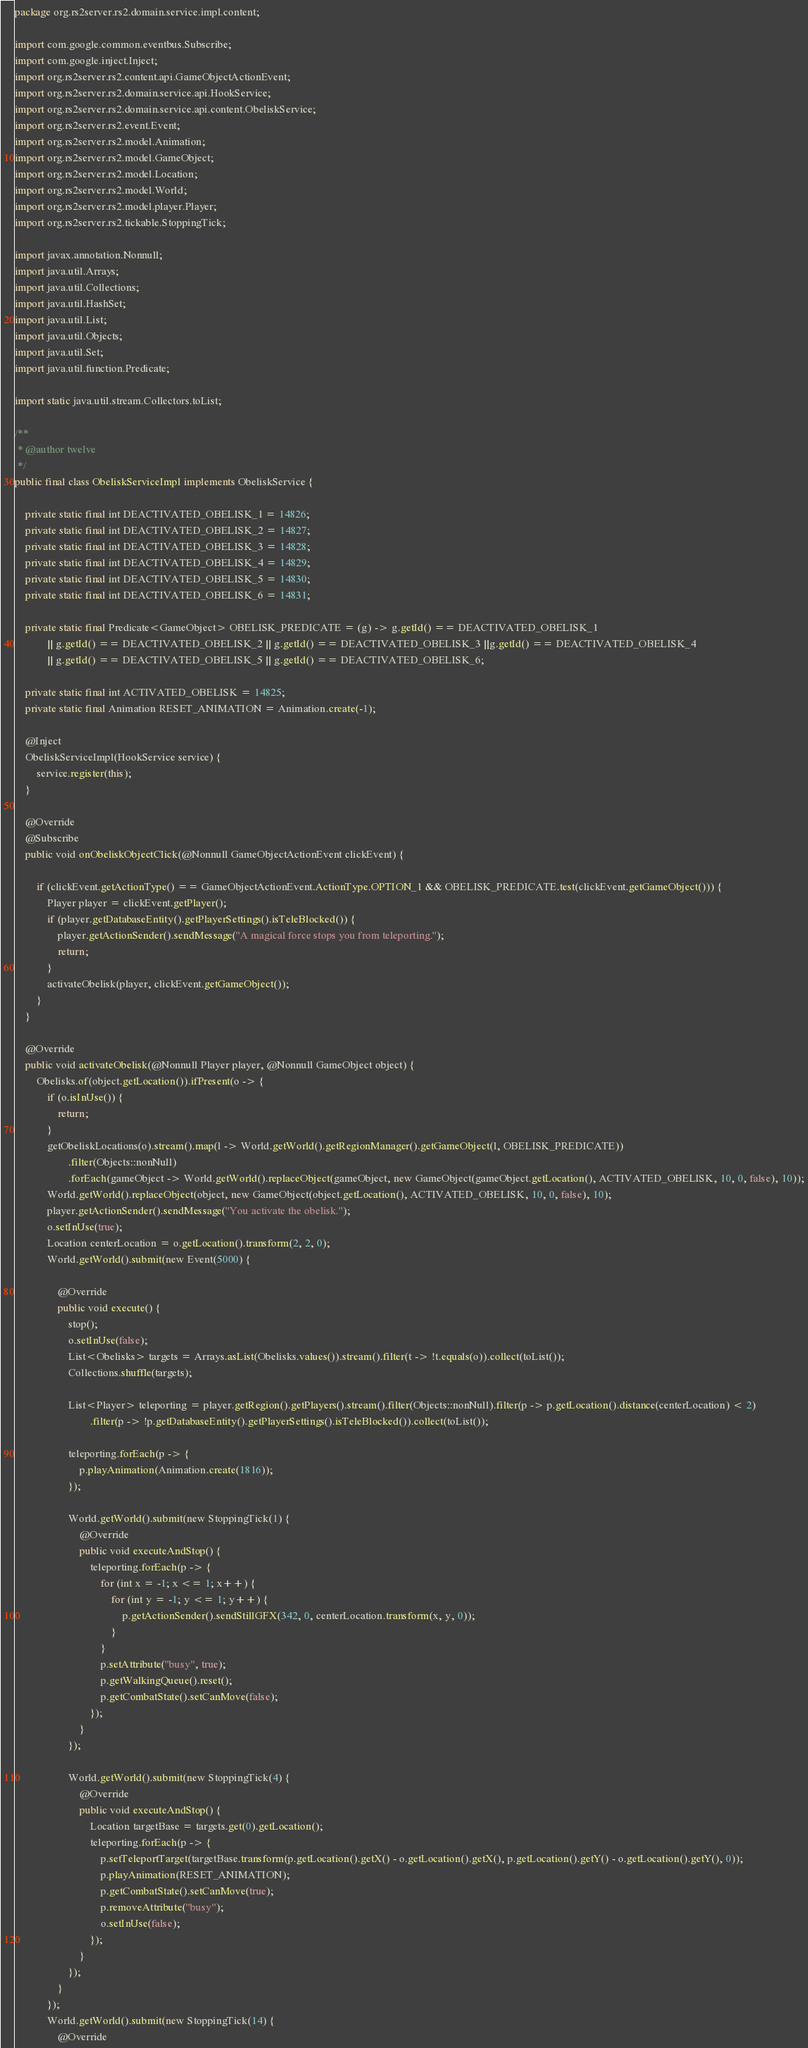Convert code to text. <code><loc_0><loc_0><loc_500><loc_500><_Java_>package org.rs2server.rs2.domain.service.impl.content;

import com.google.common.eventbus.Subscribe;
import com.google.inject.Inject;
import org.rs2server.rs2.content.api.GameObjectActionEvent;
import org.rs2server.rs2.domain.service.api.HookService;
import org.rs2server.rs2.domain.service.api.content.ObeliskService;
import org.rs2server.rs2.event.Event;
import org.rs2server.rs2.model.Animation;
import org.rs2server.rs2.model.GameObject;
import org.rs2server.rs2.model.Location;
import org.rs2server.rs2.model.World;
import org.rs2server.rs2.model.player.Player;
import org.rs2server.rs2.tickable.StoppingTick;

import javax.annotation.Nonnull;
import java.util.Arrays;
import java.util.Collections;
import java.util.HashSet;
import java.util.List;
import java.util.Objects;
import java.util.Set;
import java.util.function.Predicate;

import static java.util.stream.Collectors.toList;

/**
 * @author twelve
 */
public final class ObeliskServiceImpl implements ObeliskService {

	private static final int DEACTIVATED_OBELISK_1 = 14826;
	private static final int DEACTIVATED_OBELISK_2 = 14827;
	private static final int DEACTIVATED_OBELISK_3 = 14828;
	private static final int DEACTIVATED_OBELISK_4 = 14829;
	private static final int DEACTIVATED_OBELISK_5 = 14830;
	private static final int DEACTIVATED_OBELISK_6 = 14831;

	private static final Predicate<GameObject> OBELISK_PREDICATE = (g) -> g.getId() == DEACTIVATED_OBELISK_1
			|| g.getId() == DEACTIVATED_OBELISK_2 || g.getId() == DEACTIVATED_OBELISK_3 ||g.getId() == DEACTIVATED_OBELISK_4
			|| g.getId() == DEACTIVATED_OBELISK_5 || g.getId() == DEACTIVATED_OBELISK_6;

	private static final int ACTIVATED_OBELISK = 14825;
	private static final Animation RESET_ANIMATION = Animation.create(-1);

	@Inject
	ObeliskServiceImpl(HookService service) {
		service.register(this);
	}

	@Override
	@Subscribe
	public void onObeliskObjectClick(@Nonnull GameObjectActionEvent clickEvent) {

		if (clickEvent.getActionType() == GameObjectActionEvent.ActionType.OPTION_1 && OBELISK_PREDICATE.test(clickEvent.getGameObject())) {
			Player player = clickEvent.getPlayer();
			if (player.getDatabaseEntity().getPlayerSettings().isTeleBlocked()) {
				player.getActionSender().sendMessage("A magical force stops you from teleporting.");
				return;
			}
			activateObelisk(player, clickEvent.getGameObject());
		}
	}

	@Override
	public void activateObelisk(@Nonnull Player player, @Nonnull GameObject object) {
		Obelisks.of(object.getLocation()).ifPresent(o -> {
			if (o.isInUse()) {
				return;
			}
			getObeliskLocations(o).stream().map(l -> World.getWorld().getRegionManager().getGameObject(l, OBELISK_PREDICATE))
					.filter(Objects::nonNull)
					.forEach(gameObject -> World.getWorld().replaceObject(gameObject, new GameObject(gameObject.getLocation(), ACTIVATED_OBELISK, 10, 0, false), 10));
			World.getWorld().replaceObject(object, new GameObject(object.getLocation(), ACTIVATED_OBELISK, 10, 0, false), 10);
			player.getActionSender().sendMessage("You activate the obelisk.");
			o.setInUse(true);
			Location centerLocation = o.getLocation().transform(2, 2, 0);
			World.getWorld().submit(new Event(5000) {

				@Override
				public void execute() {
					stop();
					o.setInUse(false);
					List<Obelisks> targets = Arrays.asList(Obelisks.values()).stream().filter(t -> !t.equals(o)).collect(toList());
					Collections.shuffle(targets);

					List<Player> teleporting = player.getRegion().getPlayers().stream().filter(Objects::nonNull).filter(p -> p.getLocation().distance(centerLocation) < 2)
							.filter(p -> !p.getDatabaseEntity().getPlayerSettings().isTeleBlocked()).collect(toList());

					teleporting.forEach(p -> {
						p.playAnimation(Animation.create(1816));
					});

					World.getWorld().submit(new StoppingTick(1) {
						@Override
						public void executeAndStop() {
							teleporting.forEach(p -> {
								for (int x = -1; x <= 1; x++) {
									for (int y = -1; y <= 1; y++) {
										p.getActionSender().sendStillGFX(342, 0, centerLocation.transform(x, y, 0));
									}
								}
								p.setAttribute("busy", true);
								p.getWalkingQueue().reset();
								p.getCombatState().setCanMove(false);
							});
						}
					});

					World.getWorld().submit(new StoppingTick(4) {
						@Override
						public void executeAndStop() {
							Location targetBase = targets.get(0).getLocation();
							teleporting.forEach(p -> {
								p.setTeleportTarget(targetBase.transform(p.getLocation().getX() - o.getLocation().getX(), p.getLocation().getY() - o.getLocation().getY(), 0));
								p.playAnimation(RESET_ANIMATION);
								p.getCombatState().setCanMove(true);
								p.removeAttribute("busy");
								o.setInUse(false);
							});
						}
					});
				}
			});
			World.getWorld().submit(new StoppingTick(14) {
				@Override</code> 